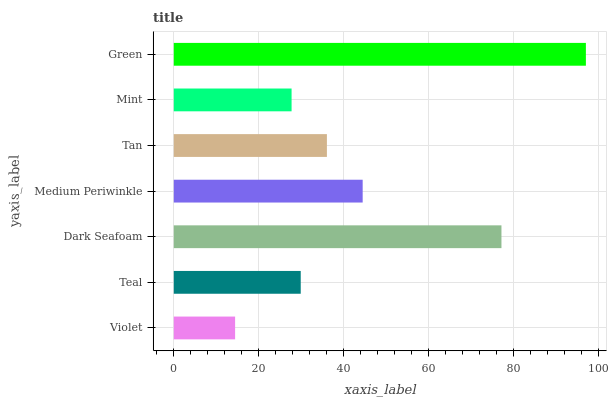Is Violet the minimum?
Answer yes or no. Yes. Is Green the maximum?
Answer yes or no. Yes. Is Teal the minimum?
Answer yes or no. No. Is Teal the maximum?
Answer yes or no. No. Is Teal greater than Violet?
Answer yes or no. Yes. Is Violet less than Teal?
Answer yes or no. Yes. Is Violet greater than Teal?
Answer yes or no. No. Is Teal less than Violet?
Answer yes or no. No. Is Tan the high median?
Answer yes or no. Yes. Is Tan the low median?
Answer yes or no. Yes. Is Medium Periwinkle the high median?
Answer yes or no. No. Is Medium Periwinkle the low median?
Answer yes or no. No. 